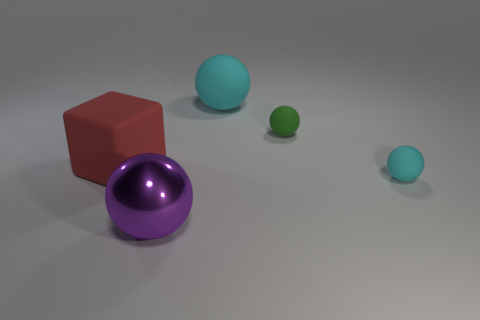Is there anything else that has the same material as the large cyan sphere?
Provide a short and direct response. Yes. What color is the matte object that is both on the right side of the big cyan sphere and in front of the green matte ball?
Give a very brief answer. Cyan. Is the tiny sphere that is in front of the big block made of the same material as the ball left of the big cyan matte ball?
Provide a succinct answer. No. Is the size of the rubber sphere in front of the green matte thing the same as the small green matte ball?
Offer a terse response. Yes. There is a large rubber ball; is it the same color as the rubber ball that is on the right side of the green ball?
Offer a very short reply. Yes. What shape is the green rubber object?
Provide a succinct answer. Sphere. What number of objects are spheres that are in front of the big matte cube or small cyan matte objects?
Offer a terse response. 2. There is a red object that is made of the same material as the green ball; what size is it?
Give a very brief answer. Large. Is the number of small spheres behind the red rubber thing greater than the number of gray blocks?
Give a very brief answer. Yes. There is a green rubber thing; does it have the same shape as the cyan rubber object behind the tiny green thing?
Offer a terse response. Yes. 